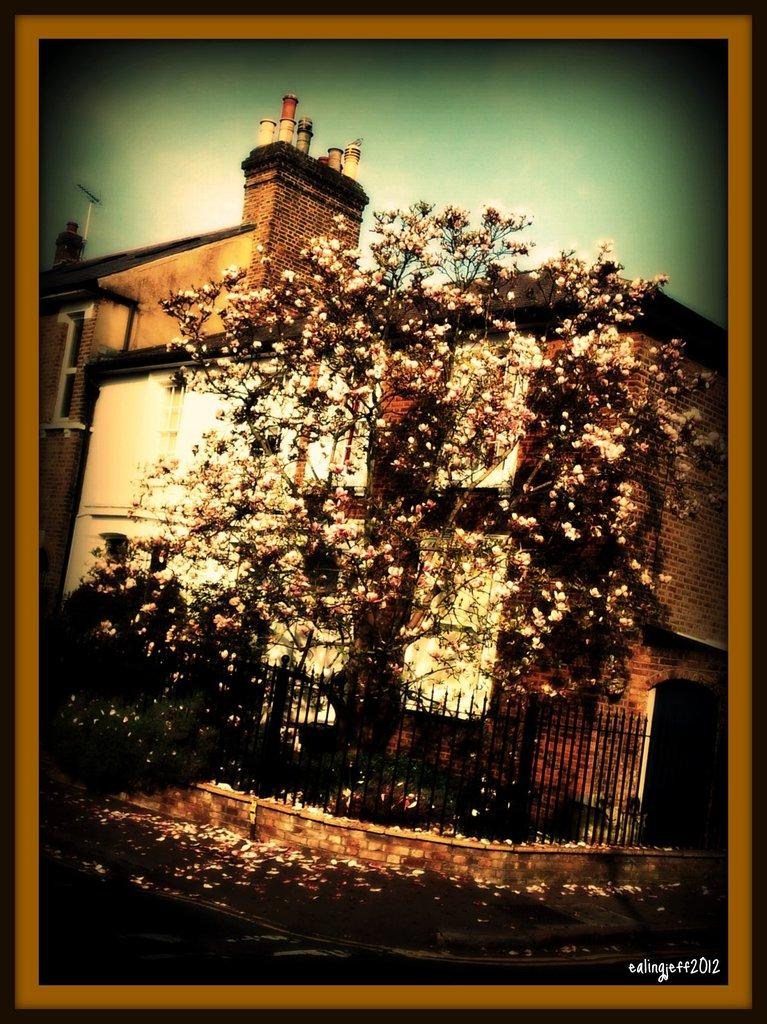What type of image is being described? The image is an edited picture. What structure can be seen in the image? There is a house in the image. What type of vegetation is present in the image? There are trees in the image. What architectural feature is visible in the image? There are iron grilles in the image. What is visible in the background of the image? The sky is visible in the background of the image. Is there any additional marking on the image? Yes, there is a watermark on the image. How many horses are present in the image? There are no horses visible in the image. What type of quiver can be seen in the image? There is no quiver present in the image. 